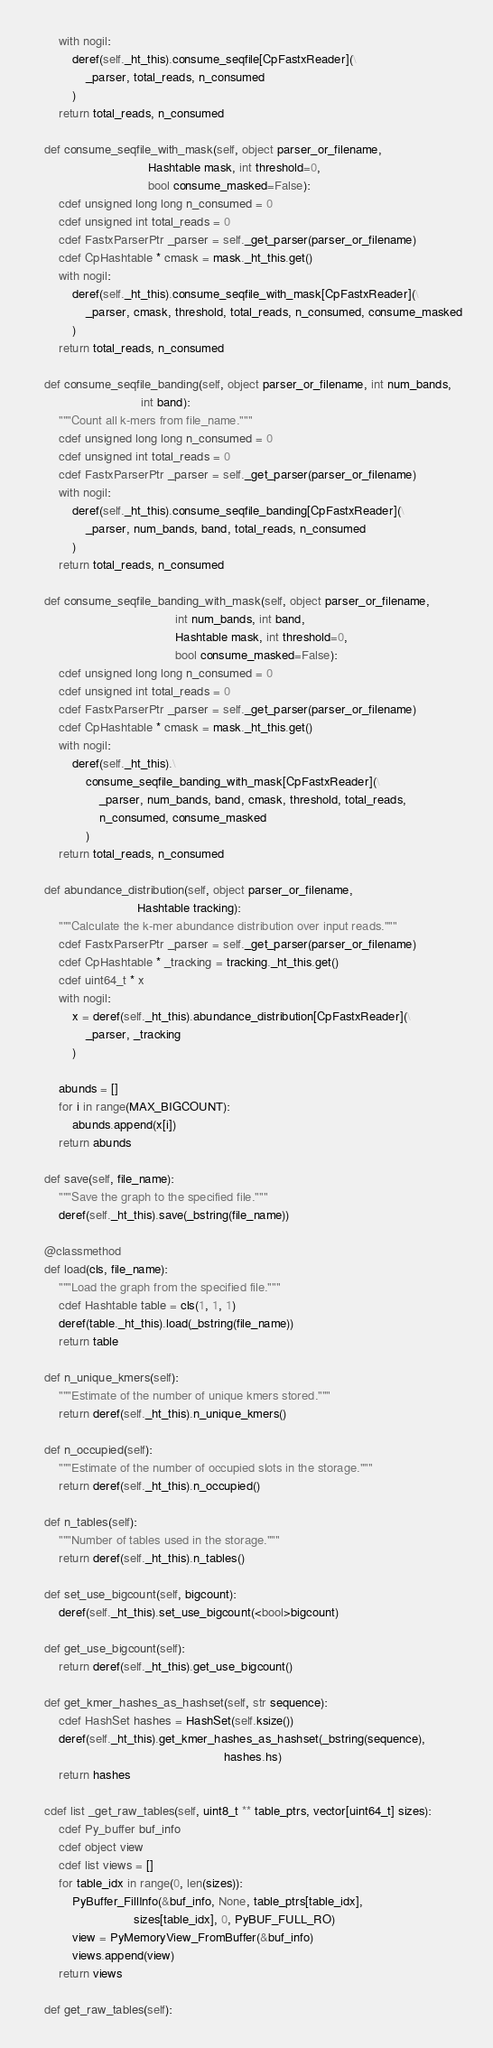<code> <loc_0><loc_0><loc_500><loc_500><_Cython_>        with nogil:
            deref(self._ht_this).consume_seqfile[CpFastxReader](\
                _parser, total_reads, n_consumed
            )
        return total_reads, n_consumed

    def consume_seqfile_with_mask(self, object parser_or_filename,
                                  Hashtable mask, int threshold=0,
                                  bool consume_masked=False):
        cdef unsigned long long n_consumed = 0
        cdef unsigned int total_reads = 0
        cdef FastxParserPtr _parser = self._get_parser(parser_or_filename)
        cdef CpHashtable * cmask = mask._ht_this.get()
        with nogil:
            deref(self._ht_this).consume_seqfile_with_mask[CpFastxReader](\
                _parser, cmask, threshold, total_reads, n_consumed, consume_masked
            )
        return total_reads, n_consumed

    def consume_seqfile_banding(self, object parser_or_filename, int num_bands,
                                int band):
        """Count all k-mers from file_name."""
        cdef unsigned long long n_consumed = 0
        cdef unsigned int total_reads = 0
        cdef FastxParserPtr _parser = self._get_parser(parser_or_filename)
        with nogil:
            deref(self._ht_this).consume_seqfile_banding[CpFastxReader](\
                _parser, num_bands, band, total_reads, n_consumed
            )
        return total_reads, n_consumed

    def consume_seqfile_banding_with_mask(self, object parser_or_filename,
                                          int num_bands, int band,
                                          Hashtable mask, int threshold=0,
                                          bool consume_masked=False):
        cdef unsigned long long n_consumed = 0
        cdef unsigned int total_reads = 0
        cdef FastxParserPtr _parser = self._get_parser(parser_or_filename)
        cdef CpHashtable * cmask = mask._ht_this.get()
        with nogil:
            deref(self._ht_this).\
                consume_seqfile_banding_with_mask[CpFastxReader](\
                    _parser, num_bands, band, cmask, threshold, total_reads,
                    n_consumed, consume_masked
                )
        return total_reads, n_consumed

    def abundance_distribution(self, object parser_or_filename,
                               Hashtable tracking):
        """Calculate the k-mer abundance distribution over input reads."""
        cdef FastxParserPtr _parser = self._get_parser(parser_or_filename)
        cdef CpHashtable * _tracking = tracking._ht_this.get()
        cdef uint64_t * x
        with nogil:
            x = deref(self._ht_this).abundance_distribution[CpFastxReader](\
                _parser, _tracking
            )

        abunds = []
        for i in range(MAX_BIGCOUNT):
            abunds.append(x[i])
        return abunds

    def save(self, file_name):
        """Save the graph to the specified file."""
        deref(self._ht_this).save(_bstring(file_name))

    @classmethod
    def load(cls, file_name):
        """Load the graph from the specified file."""
        cdef Hashtable table = cls(1, 1, 1)
        deref(table._ht_this).load(_bstring(file_name))
        return table

    def n_unique_kmers(self):
        """Estimate of the number of unique kmers stored."""
        return deref(self._ht_this).n_unique_kmers()

    def n_occupied(self):
        """Estimate of the number of occupied slots in the storage."""
        return deref(self._ht_this).n_occupied()

    def n_tables(self):
        """Number of tables used in the storage."""
        return deref(self._ht_this).n_tables()

    def set_use_bigcount(self, bigcount):
        deref(self._ht_this).set_use_bigcount(<bool>bigcount)

    def get_use_bigcount(self):
        return deref(self._ht_this).get_use_bigcount()

    def get_kmer_hashes_as_hashset(self, str sequence):
        cdef HashSet hashes = HashSet(self.ksize())
        deref(self._ht_this).get_kmer_hashes_as_hashset(_bstring(sequence),
                                                        hashes.hs)
        return hashes

    cdef list _get_raw_tables(self, uint8_t ** table_ptrs, vector[uint64_t] sizes):
        cdef Py_buffer buf_info
        cdef object view
        cdef list views = []
        for table_idx in range(0, len(sizes)):
            PyBuffer_FillInfo(&buf_info, None, table_ptrs[table_idx],
                              sizes[table_idx], 0, PyBUF_FULL_RO)
            view = PyMemoryView_FromBuffer(&buf_info)
            views.append(view)
        return views

    def get_raw_tables(self):</code> 